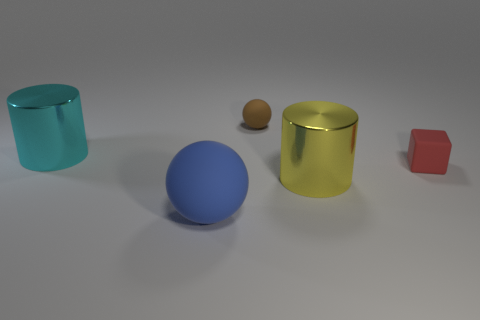There is a big blue matte object to the left of the metallic cylinder that is in front of the object that is to the left of the big blue thing; what shape is it?
Ensure brevity in your answer.  Sphere. There is a small red rubber object; what shape is it?
Make the answer very short. Cube. What is the color of the big thing that is behind the small red rubber thing?
Keep it short and to the point. Cyan. Does the cylinder to the left of the blue rubber object have the same size as the blue rubber sphere?
Provide a succinct answer. Yes. There is a blue thing that is the same shape as the small brown thing; what size is it?
Your answer should be very brief. Large. Is there any other thing that is the same size as the blue thing?
Your answer should be very brief. Yes. Is the big rubber object the same shape as the yellow shiny object?
Offer a terse response. No. Is the number of cyan things that are right of the tiny matte cube less than the number of big yellow cylinders behind the cyan thing?
Provide a succinct answer. No. There is a small brown thing; what number of large cyan shiny cylinders are to the left of it?
Keep it short and to the point. 1. Is the shape of the shiny object that is in front of the large cyan cylinder the same as the matte thing behind the large cyan cylinder?
Ensure brevity in your answer.  No. 